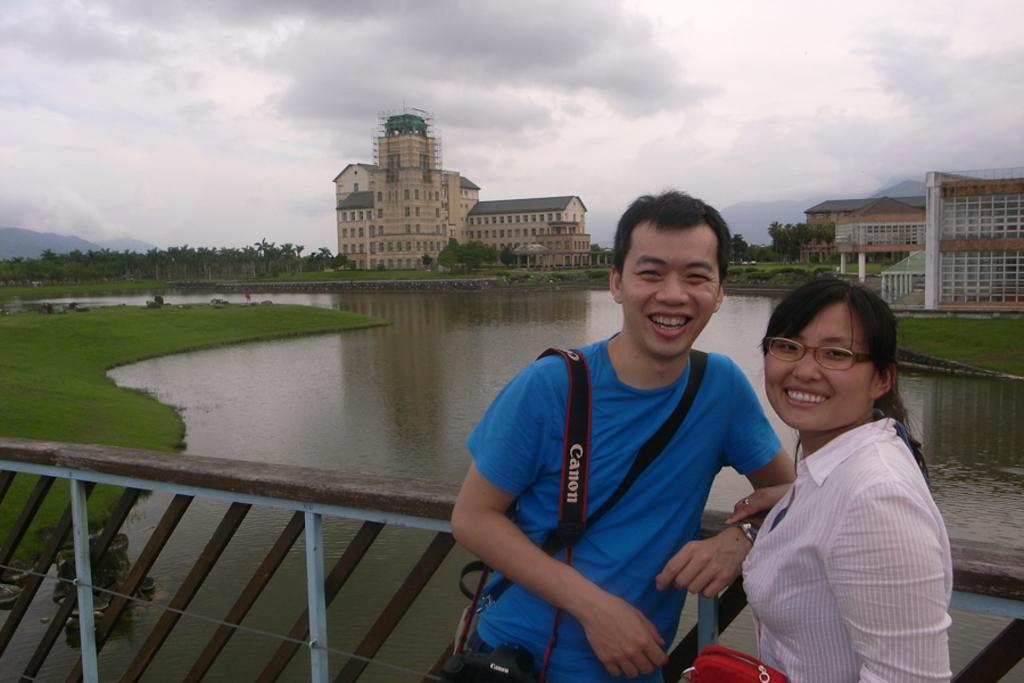<image>
Present a compact description of the photo's key features. a man that has the word Canon on his strap 